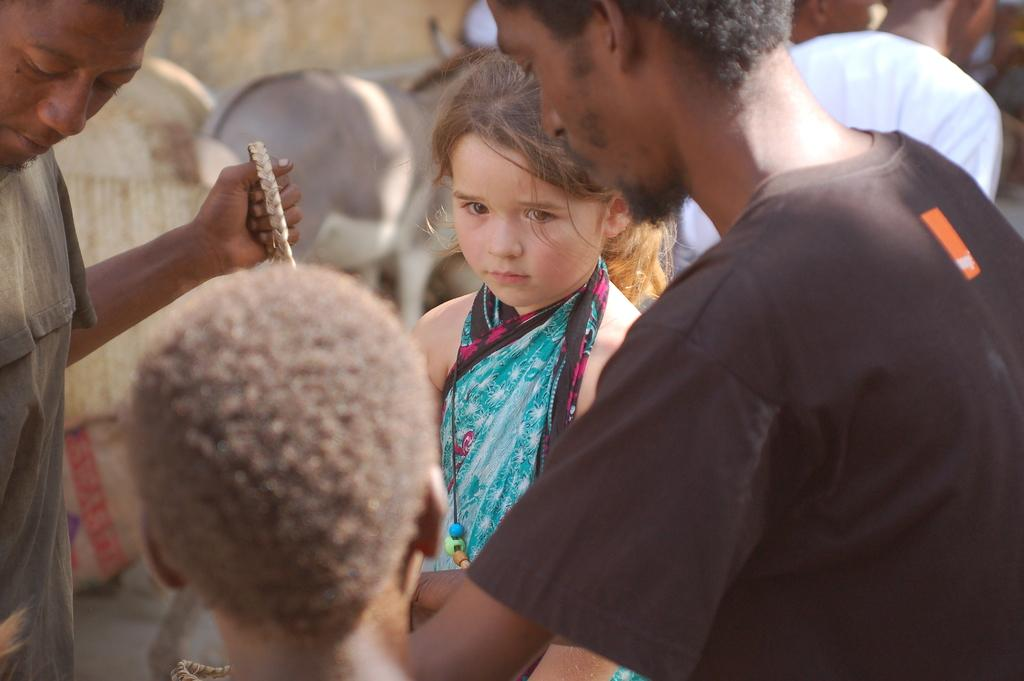How many people are visible in the image? There are many people in the image. Can you describe the girl in the front of the image? The girl in the front of the image is wearing blue colored clothes. What type of animal can be seen in the background of the image? There is an animal in the background of the image, and it appears to be a donkey. What type of baseball meal is the girl eating in the image? There is no baseball or meal present in the image; the girl is not eating anything. What treatment is the donkey receiving in the image? There is no indication in the image that the donkey is receiving any treatment. 